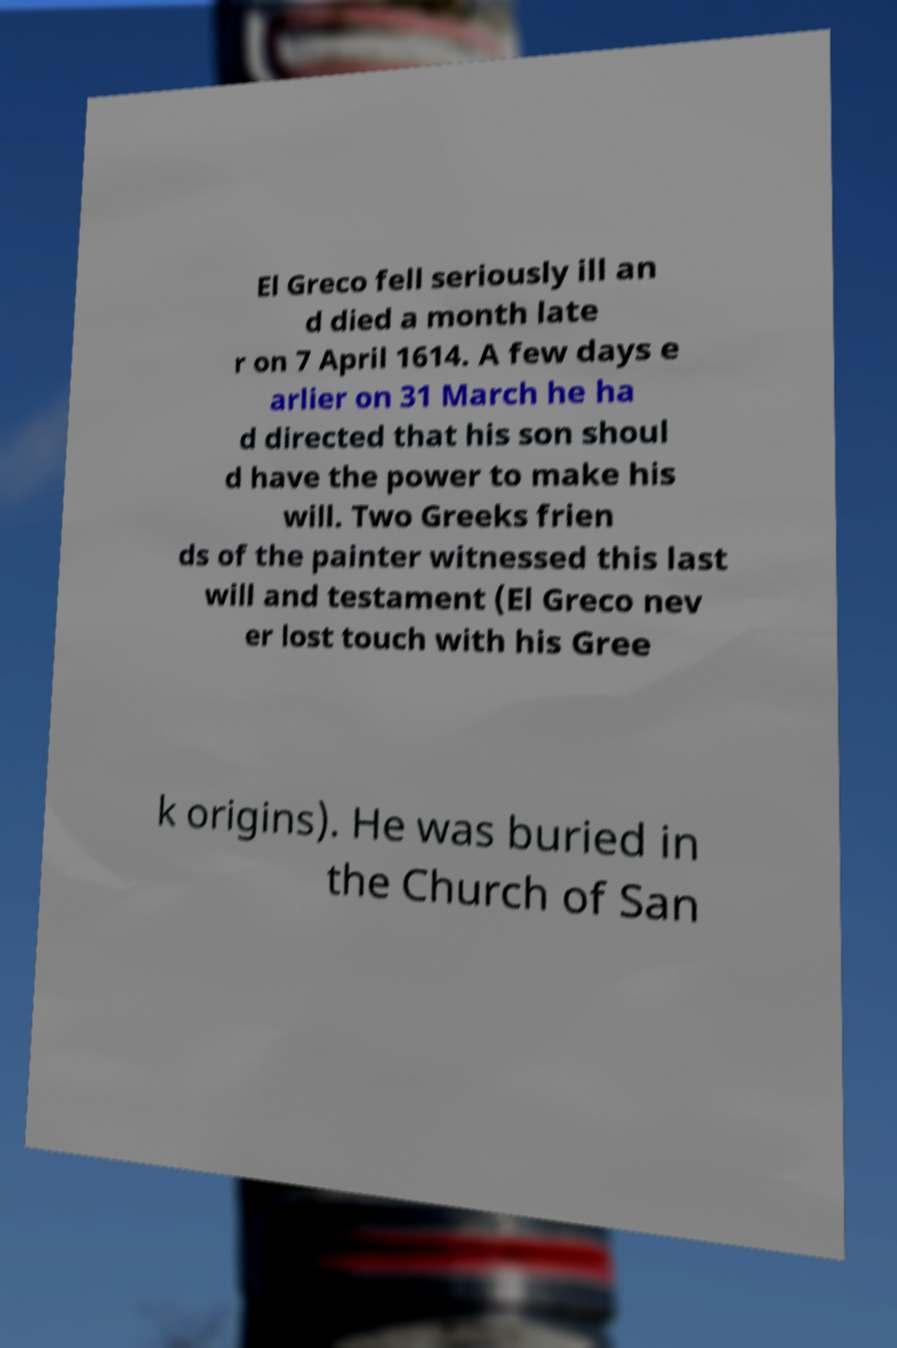Could you extract and type out the text from this image? El Greco fell seriously ill an d died a month late r on 7 April 1614. A few days e arlier on 31 March he ha d directed that his son shoul d have the power to make his will. Two Greeks frien ds of the painter witnessed this last will and testament (El Greco nev er lost touch with his Gree k origins). He was buried in the Church of San 